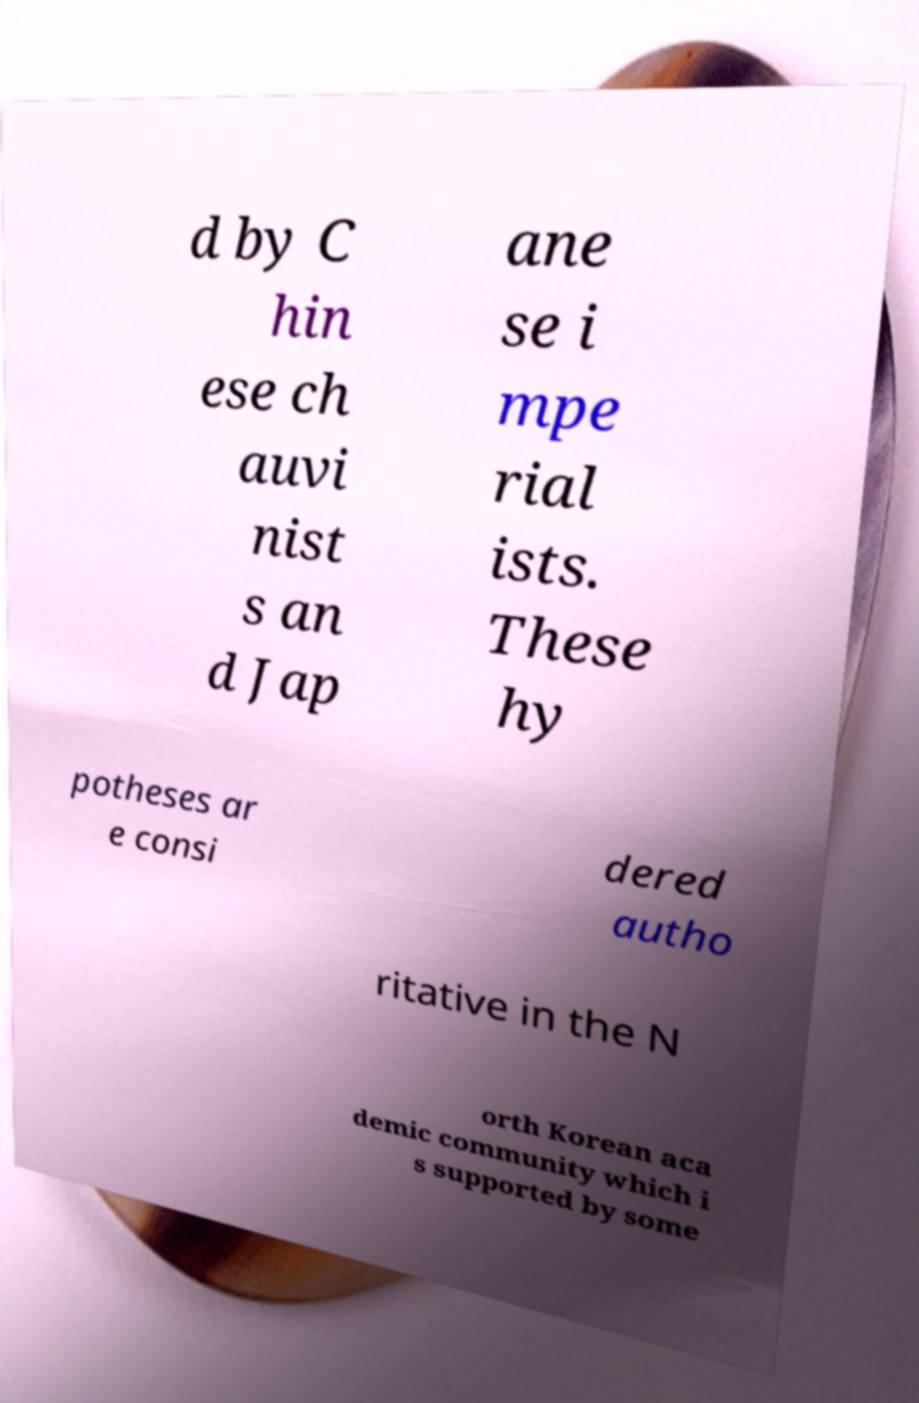Please identify and transcribe the text found in this image. d by C hin ese ch auvi nist s an d Jap ane se i mpe rial ists. These hy potheses ar e consi dered autho ritative in the N orth Korean aca demic community which i s supported by some 